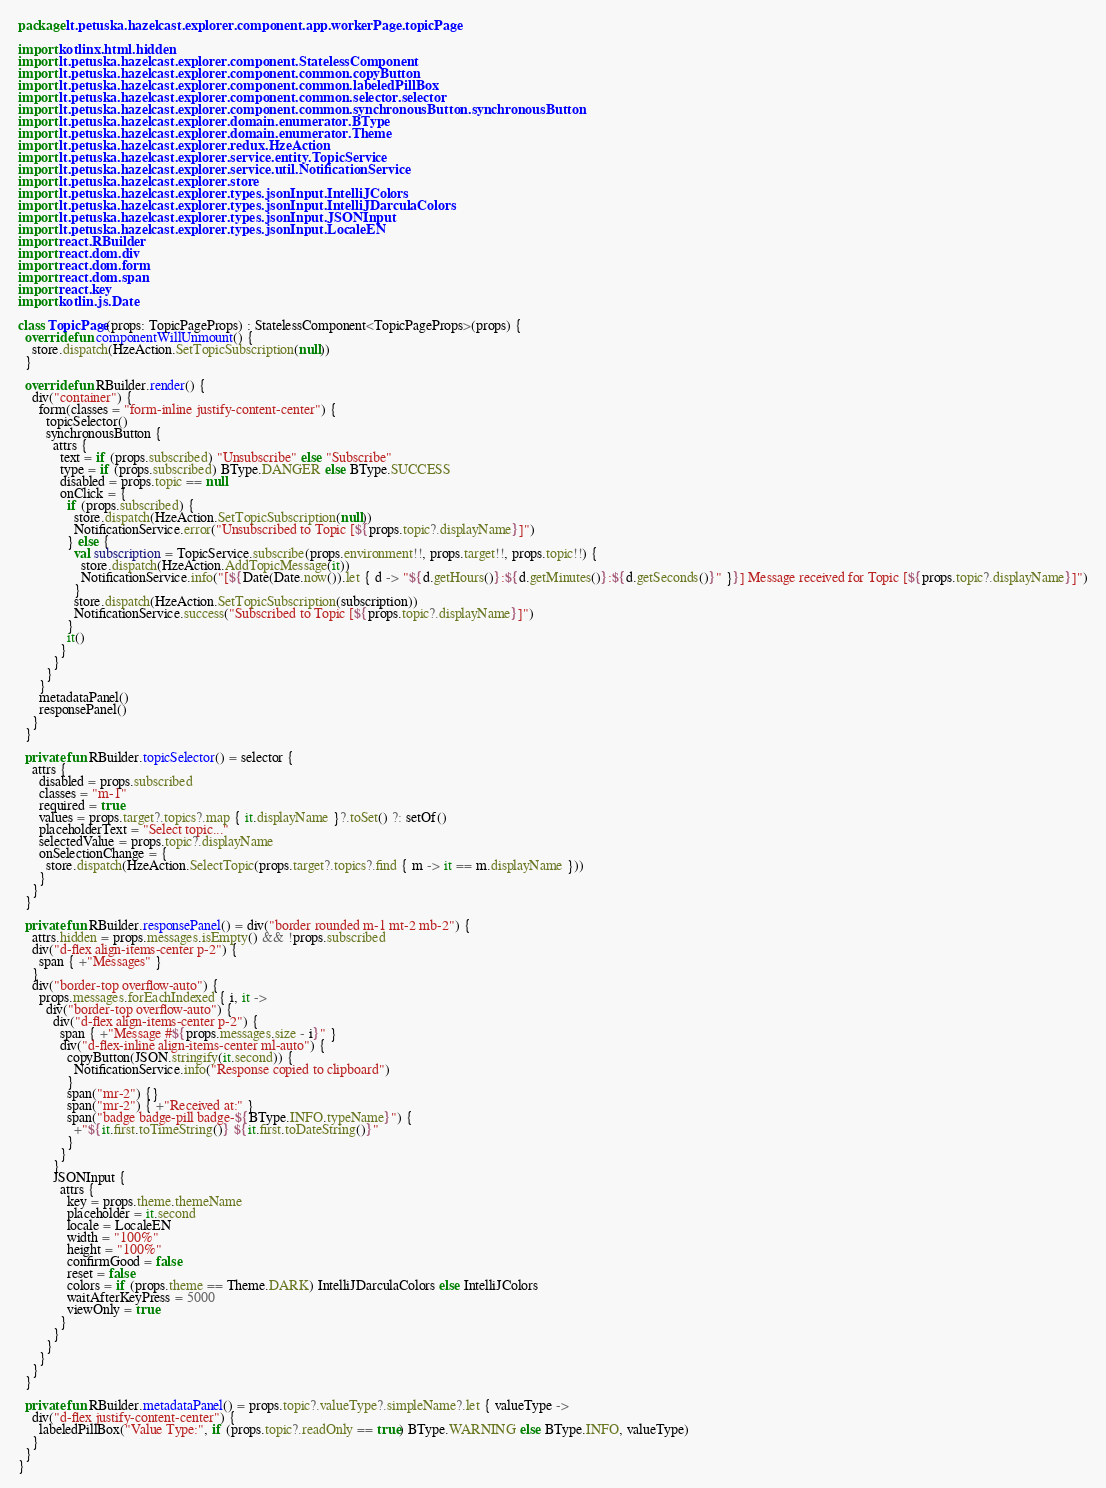<code> <loc_0><loc_0><loc_500><loc_500><_Kotlin_>package lt.petuska.hazelcast.explorer.component.app.workerPage.topicPage

import kotlinx.html.hidden
import lt.petuska.hazelcast.explorer.component.StatelessComponent
import lt.petuska.hazelcast.explorer.component.common.copyButton
import lt.petuska.hazelcast.explorer.component.common.labeledPillBox
import lt.petuska.hazelcast.explorer.component.common.selector.selector
import lt.petuska.hazelcast.explorer.component.common.synchronousButton.synchronousButton
import lt.petuska.hazelcast.explorer.domain.enumerator.BType
import lt.petuska.hazelcast.explorer.domain.enumerator.Theme
import lt.petuska.hazelcast.explorer.redux.HzeAction
import lt.petuska.hazelcast.explorer.service.entity.TopicService
import lt.petuska.hazelcast.explorer.service.util.NotificationService
import lt.petuska.hazelcast.explorer.store
import lt.petuska.hazelcast.explorer.types.jsonInput.IntelliJColors
import lt.petuska.hazelcast.explorer.types.jsonInput.IntelliJDarculaColors
import lt.petuska.hazelcast.explorer.types.jsonInput.JSONInput
import lt.petuska.hazelcast.explorer.types.jsonInput.LocaleEN
import react.RBuilder
import react.dom.div
import react.dom.form
import react.dom.span
import react.key
import kotlin.js.Date

class TopicPage(props: TopicPageProps) : StatelessComponent<TopicPageProps>(props) {
  override fun componentWillUnmount() {
    store.dispatch(HzeAction.SetTopicSubscription(null))
  }
  
  override fun RBuilder.render() {
    div("container") {
      form(classes = "form-inline justify-content-center") {
        topicSelector()
        synchronousButton {
          attrs {
            text = if (props.subscribed) "Unsubscribe" else "Subscribe"
            type = if (props.subscribed) BType.DANGER else BType.SUCCESS
            disabled = props.topic == null
            onClick = {
              if (props.subscribed) {
                store.dispatch(HzeAction.SetTopicSubscription(null))
                NotificationService.error("Unsubscribed to Topic [${props.topic?.displayName}]")
              } else {
                val subscription = TopicService.subscribe(props.environment!!, props.target!!, props.topic!!) {
                  store.dispatch(HzeAction.AddTopicMessage(it))
                  NotificationService.info("[${Date(Date.now()).let { d -> "${d.getHours()}:${d.getMinutes()}:${d.getSeconds()}" }}] Message received for Topic [${props.topic?.displayName}]")
                }
                store.dispatch(HzeAction.SetTopicSubscription(subscription))
                NotificationService.success("Subscribed to Topic [${props.topic?.displayName}]")
              }
              it()
            }
          }
        }
      }
      metadataPanel()
      responsePanel()
    }
  }
  
  private fun RBuilder.topicSelector() = selector {
    attrs {
      disabled = props.subscribed
      classes = "m-1"
      required = true
      values = props.target?.topics?.map { it.displayName }?.toSet() ?: setOf()
      placeholderText = "Select topic..."
      selectedValue = props.topic?.displayName
      onSelectionChange = {
        store.dispatch(HzeAction.SelectTopic(props.target?.topics?.find { m -> it == m.displayName }))
      }
    }
  }
  
  private fun RBuilder.responsePanel() = div("border rounded m-1 mt-2 mb-2") {
    attrs.hidden = props.messages.isEmpty() && !props.subscribed
    div("d-flex align-items-center p-2") {
      span { +"Messages" }
    }
    div("border-top overflow-auto") {
      props.messages.forEachIndexed { i, it ->
        div("border-top overflow-auto") {
          div("d-flex align-items-center p-2") {
            span { +"Message #${props.messages.size - i}" }
            div("d-flex-inline align-items-center ml-auto") {
              copyButton(JSON.stringify(it.second)) {
                NotificationService.info("Response copied to clipboard")
              }
              span("mr-2") {}
              span("mr-2") { +"Received at:" }
              span("badge badge-pill badge-${BType.INFO.typeName}") {
                +"${it.first.toTimeString()} ${it.first.toDateString()}"
              }
            }
          }
          JSONInput {
            attrs {
              key = props.theme.themeName
              placeholder = it.second
              locale = LocaleEN
              width = "100%"
              height = "100%"
              confirmGood = false
              reset = false
              colors = if (props.theme == Theme.DARK) IntelliJDarculaColors else IntelliJColors
              waitAfterKeyPress = 5000
              viewOnly = true
            }
          }
        }
      }
    }
  }
  
  private fun RBuilder.metadataPanel() = props.topic?.valueType?.simpleName?.let { valueType ->
    div("d-flex justify-content-center") {
      labeledPillBox("Value Type:", if (props.topic?.readOnly == true) BType.WARNING else BType.INFO, valueType)
    }
  }
}</code> 